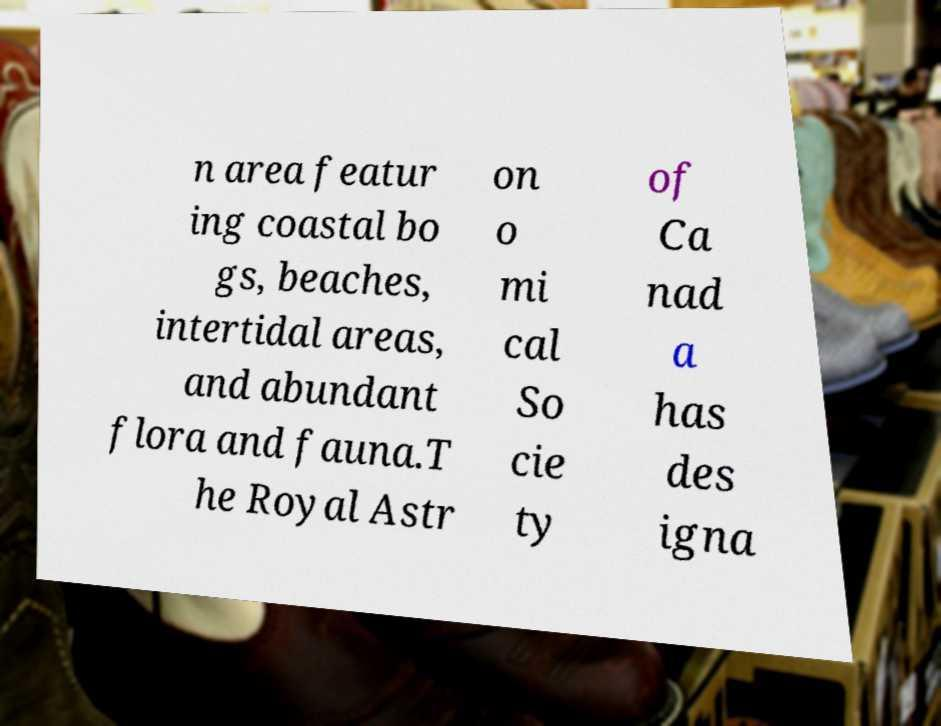Please read and relay the text visible in this image. What does it say? n area featur ing coastal bo gs, beaches, intertidal areas, and abundant flora and fauna.T he Royal Astr on o mi cal So cie ty of Ca nad a has des igna 